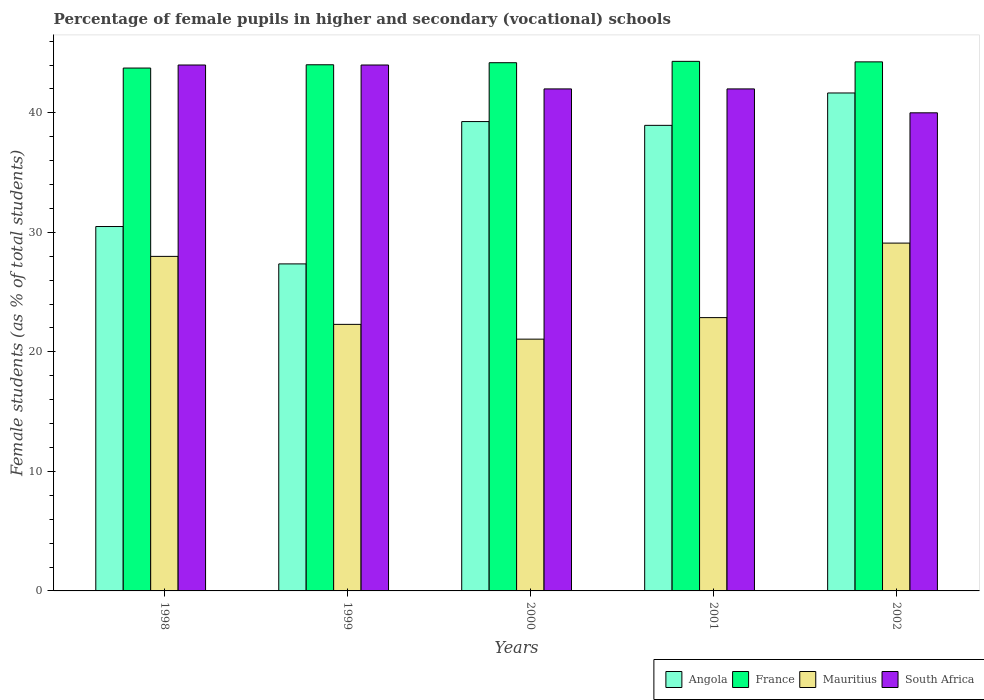How many different coloured bars are there?
Keep it short and to the point. 4. Are the number of bars on each tick of the X-axis equal?
Your answer should be compact. Yes. In how many cases, is the number of bars for a given year not equal to the number of legend labels?
Offer a terse response. 0. What is the percentage of female pupils in higher and secondary schools in France in 2002?
Provide a short and direct response. 44.26. Across all years, what is the maximum percentage of female pupils in higher and secondary schools in Mauritius?
Give a very brief answer. 29.1. Across all years, what is the minimum percentage of female pupils in higher and secondary schools in France?
Offer a very short reply. 43.74. In which year was the percentage of female pupils in higher and secondary schools in France maximum?
Your answer should be compact. 2001. In which year was the percentage of female pupils in higher and secondary schools in South Africa minimum?
Offer a terse response. 2002. What is the total percentage of female pupils in higher and secondary schools in Angola in the graph?
Make the answer very short. 177.72. What is the difference between the percentage of female pupils in higher and secondary schools in Mauritius in 1998 and that in 2001?
Offer a very short reply. 5.12. What is the difference between the percentage of female pupils in higher and secondary schools in France in 1998 and the percentage of female pupils in higher and secondary schools in Mauritius in 2001?
Keep it short and to the point. 20.88. What is the average percentage of female pupils in higher and secondary schools in Angola per year?
Give a very brief answer. 35.54. In the year 1998, what is the difference between the percentage of female pupils in higher and secondary schools in France and percentage of female pupils in higher and secondary schools in South Africa?
Keep it short and to the point. -0.26. What is the ratio of the percentage of female pupils in higher and secondary schools in Angola in 2000 to that in 2002?
Give a very brief answer. 0.94. Is the difference between the percentage of female pupils in higher and secondary schools in France in 1998 and 1999 greater than the difference between the percentage of female pupils in higher and secondary schools in South Africa in 1998 and 1999?
Provide a short and direct response. No. What is the difference between the highest and the second highest percentage of female pupils in higher and secondary schools in France?
Your answer should be very brief. 0.04. What is the difference between the highest and the lowest percentage of female pupils in higher and secondary schools in South Africa?
Your answer should be compact. 4. In how many years, is the percentage of female pupils in higher and secondary schools in South Africa greater than the average percentage of female pupils in higher and secondary schools in South Africa taken over all years?
Your response must be concise. 2. Is the sum of the percentage of female pupils in higher and secondary schools in Angola in 1999 and 2000 greater than the maximum percentage of female pupils in higher and secondary schools in Mauritius across all years?
Ensure brevity in your answer.  Yes. Is it the case that in every year, the sum of the percentage of female pupils in higher and secondary schools in Mauritius and percentage of female pupils in higher and secondary schools in Angola is greater than the sum of percentage of female pupils in higher and secondary schools in South Africa and percentage of female pupils in higher and secondary schools in France?
Give a very brief answer. No. What does the 3rd bar from the left in 2001 represents?
Your response must be concise. Mauritius. What does the 2nd bar from the right in 1999 represents?
Give a very brief answer. Mauritius. Are all the bars in the graph horizontal?
Provide a succinct answer. No. Does the graph contain any zero values?
Your answer should be compact. No. Where does the legend appear in the graph?
Offer a very short reply. Bottom right. How many legend labels are there?
Ensure brevity in your answer.  4. What is the title of the graph?
Give a very brief answer. Percentage of female pupils in higher and secondary (vocational) schools. What is the label or title of the X-axis?
Offer a very short reply. Years. What is the label or title of the Y-axis?
Ensure brevity in your answer.  Female students (as % of total students). What is the Female students (as % of total students) in Angola in 1998?
Your answer should be compact. 30.49. What is the Female students (as % of total students) in France in 1998?
Keep it short and to the point. 43.74. What is the Female students (as % of total students) in Mauritius in 1998?
Offer a terse response. 27.99. What is the Female students (as % of total students) of South Africa in 1998?
Give a very brief answer. 44. What is the Female students (as % of total students) of Angola in 1999?
Your answer should be compact. 27.36. What is the Female students (as % of total students) of France in 1999?
Offer a terse response. 44.02. What is the Female students (as % of total students) in Mauritius in 1999?
Your answer should be compact. 22.3. What is the Female students (as % of total students) of South Africa in 1999?
Give a very brief answer. 44. What is the Female students (as % of total students) of Angola in 2000?
Give a very brief answer. 39.27. What is the Female students (as % of total students) of France in 2000?
Make the answer very short. 44.19. What is the Female students (as % of total students) of Mauritius in 2000?
Ensure brevity in your answer.  21.06. What is the Female students (as % of total students) in South Africa in 2000?
Provide a succinct answer. 42. What is the Female students (as % of total students) of Angola in 2001?
Your answer should be compact. 38.95. What is the Female students (as % of total students) in France in 2001?
Provide a short and direct response. 44.31. What is the Female students (as % of total students) in Mauritius in 2001?
Make the answer very short. 22.86. What is the Female students (as % of total students) of South Africa in 2001?
Provide a succinct answer. 42. What is the Female students (as % of total students) of Angola in 2002?
Provide a succinct answer. 41.66. What is the Female students (as % of total students) of France in 2002?
Offer a terse response. 44.26. What is the Female students (as % of total students) of Mauritius in 2002?
Ensure brevity in your answer.  29.1. What is the Female students (as % of total students) of South Africa in 2002?
Offer a terse response. 40. Across all years, what is the maximum Female students (as % of total students) of Angola?
Make the answer very short. 41.66. Across all years, what is the maximum Female students (as % of total students) in France?
Make the answer very short. 44.31. Across all years, what is the maximum Female students (as % of total students) of Mauritius?
Provide a succinct answer. 29.1. Across all years, what is the maximum Female students (as % of total students) of South Africa?
Provide a succinct answer. 44. Across all years, what is the minimum Female students (as % of total students) in Angola?
Ensure brevity in your answer.  27.36. Across all years, what is the minimum Female students (as % of total students) in France?
Make the answer very short. 43.74. Across all years, what is the minimum Female students (as % of total students) in Mauritius?
Your answer should be very brief. 21.06. Across all years, what is the minimum Female students (as % of total students) of South Africa?
Ensure brevity in your answer.  40. What is the total Female students (as % of total students) of Angola in the graph?
Keep it short and to the point. 177.72. What is the total Female students (as % of total students) in France in the graph?
Provide a succinct answer. 220.52. What is the total Female students (as % of total students) in Mauritius in the graph?
Your response must be concise. 123.32. What is the total Female students (as % of total students) of South Africa in the graph?
Give a very brief answer. 212. What is the difference between the Female students (as % of total students) of Angola in 1998 and that in 1999?
Provide a short and direct response. 3.13. What is the difference between the Female students (as % of total students) of France in 1998 and that in 1999?
Offer a terse response. -0.27. What is the difference between the Female students (as % of total students) in Mauritius in 1998 and that in 1999?
Give a very brief answer. 5.69. What is the difference between the Female students (as % of total students) of Angola in 1998 and that in 2000?
Your answer should be very brief. -8.78. What is the difference between the Female students (as % of total students) of France in 1998 and that in 2000?
Provide a short and direct response. -0.45. What is the difference between the Female students (as % of total students) in Mauritius in 1998 and that in 2000?
Your answer should be very brief. 6.92. What is the difference between the Female students (as % of total students) of South Africa in 1998 and that in 2000?
Ensure brevity in your answer.  2. What is the difference between the Female students (as % of total students) in Angola in 1998 and that in 2001?
Your response must be concise. -8.46. What is the difference between the Female students (as % of total students) of France in 1998 and that in 2001?
Make the answer very short. -0.56. What is the difference between the Female students (as % of total students) of Mauritius in 1998 and that in 2001?
Keep it short and to the point. 5.12. What is the difference between the Female students (as % of total students) of South Africa in 1998 and that in 2001?
Offer a very short reply. 2. What is the difference between the Female students (as % of total students) of Angola in 1998 and that in 2002?
Provide a succinct answer. -11.17. What is the difference between the Female students (as % of total students) of France in 1998 and that in 2002?
Your response must be concise. -0.52. What is the difference between the Female students (as % of total students) in Mauritius in 1998 and that in 2002?
Offer a terse response. -1.11. What is the difference between the Female students (as % of total students) of South Africa in 1998 and that in 2002?
Offer a very short reply. 4. What is the difference between the Female students (as % of total students) in Angola in 1999 and that in 2000?
Your answer should be compact. -11.91. What is the difference between the Female students (as % of total students) of France in 1999 and that in 2000?
Your answer should be compact. -0.17. What is the difference between the Female students (as % of total students) in Mauritius in 1999 and that in 2000?
Your answer should be compact. 1.24. What is the difference between the Female students (as % of total students) in South Africa in 1999 and that in 2000?
Offer a very short reply. 2. What is the difference between the Female students (as % of total students) of Angola in 1999 and that in 2001?
Keep it short and to the point. -11.59. What is the difference between the Female students (as % of total students) in France in 1999 and that in 2001?
Ensure brevity in your answer.  -0.29. What is the difference between the Female students (as % of total students) in Mauritius in 1999 and that in 2001?
Offer a very short reply. -0.56. What is the difference between the Female students (as % of total students) of South Africa in 1999 and that in 2001?
Offer a very short reply. 2. What is the difference between the Female students (as % of total students) of Angola in 1999 and that in 2002?
Ensure brevity in your answer.  -14.3. What is the difference between the Female students (as % of total students) of France in 1999 and that in 2002?
Give a very brief answer. -0.24. What is the difference between the Female students (as % of total students) in Mauritius in 1999 and that in 2002?
Keep it short and to the point. -6.8. What is the difference between the Female students (as % of total students) in South Africa in 1999 and that in 2002?
Your answer should be very brief. 4. What is the difference between the Female students (as % of total students) of Angola in 2000 and that in 2001?
Offer a very short reply. 0.32. What is the difference between the Female students (as % of total students) in France in 2000 and that in 2001?
Give a very brief answer. -0.11. What is the difference between the Female students (as % of total students) in Mauritius in 2000 and that in 2001?
Offer a very short reply. -1.8. What is the difference between the Female students (as % of total students) of South Africa in 2000 and that in 2001?
Ensure brevity in your answer.  0. What is the difference between the Female students (as % of total students) in Angola in 2000 and that in 2002?
Give a very brief answer. -2.39. What is the difference between the Female students (as % of total students) in France in 2000 and that in 2002?
Your answer should be very brief. -0.07. What is the difference between the Female students (as % of total students) of Mauritius in 2000 and that in 2002?
Give a very brief answer. -8.04. What is the difference between the Female students (as % of total students) of South Africa in 2000 and that in 2002?
Provide a succinct answer. 2. What is the difference between the Female students (as % of total students) in Angola in 2001 and that in 2002?
Your answer should be compact. -2.71. What is the difference between the Female students (as % of total students) in France in 2001 and that in 2002?
Your response must be concise. 0.04. What is the difference between the Female students (as % of total students) in Mauritius in 2001 and that in 2002?
Your response must be concise. -6.24. What is the difference between the Female students (as % of total students) in South Africa in 2001 and that in 2002?
Offer a very short reply. 2. What is the difference between the Female students (as % of total students) in Angola in 1998 and the Female students (as % of total students) in France in 1999?
Your response must be concise. -13.53. What is the difference between the Female students (as % of total students) in Angola in 1998 and the Female students (as % of total students) in Mauritius in 1999?
Keep it short and to the point. 8.19. What is the difference between the Female students (as % of total students) in Angola in 1998 and the Female students (as % of total students) in South Africa in 1999?
Offer a very short reply. -13.51. What is the difference between the Female students (as % of total students) in France in 1998 and the Female students (as % of total students) in Mauritius in 1999?
Ensure brevity in your answer.  21.44. What is the difference between the Female students (as % of total students) in France in 1998 and the Female students (as % of total students) in South Africa in 1999?
Offer a very short reply. -0.26. What is the difference between the Female students (as % of total students) of Mauritius in 1998 and the Female students (as % of total students) of South Africa in 1999?
Make the answer very short. -16.01. What is the difference between the Female students (as % of total students) of Angola in 1998 and the Female students (as % of total students) of France in 2000?
Make the answer very short. -13.71. What is the difference between the Female students (as % of total students) in Angola in 1998 and the Female students (as % of total students) in Mauritius in 2000?
Ensure brevity in your answer.  9.42. What is the difference between the Female students (as % of total students) in Angola in 1998 and the Female students (as % of total students) in South Africa in 2000?
Your answer should be compact. -11.51. What is the difference between the Female students (as % of total students) in France in 1998 and the Female students (as % of total students) in Mauritius in 2000?
Make the answer very short. 22.68. What is the difference between the Female students (as % of total students) of France in 1998 and the Female students (as % of total students) of South Africa in 2000?
Make the answer very short. 1.74. What is the difference between the Female students (as % of total students) in Mauritius in 1998 and the Female students (as % of total students) in South Africa in 2000?
Offer a terse response. -14.01. What is the difference between the Female students (as % of total students) of Angola in 1998 and the Female students (as % of total students) of France in 2001?
Ensure brevity in your answer.  -13.82. What is the difference between the Female students (as % of total students) of Angola in 1998 and the Female students (as % of total students) of Mauritius in 2001?
Your answer should be compact. 7.62. What is the difference between the Female students (as % of total students) in Angola in 1998 and the Female students (as % of total students) in South Africa in 2001?
Provide a succinct answer. -11.51. What is the difference between the Female students (as % of total students) of France in 1998 and the Female students (as % of total students) of Mauritius in 2001?
Keep it short and to the point. 20.88. What is the difference between the Female students (as % of total students) in France in 1998 and the Female students (as % of total students) in South Africa in 2001?
Make the answer very short. 1.74. What is the difference between the Female students (as % of total students) in Mauritius in 1998 and the Female students (as % of total students) in South Africa in 2001?
Offer a very short reply. -14.01. What is the difference between the Female students (as % of total students) in Angola in 1998 and the Female students (as % of total students) in France in 2002?
Ensure brevity in your answer.  -13.78. What is the difference between the Female students (as % of total students) in Angola in 1998 and the Female students (as % of total students) in Mauritius in 2002?
Give a very brief answer. 1.39. What is the difference between the Female students (as % of total students) in Angola in 1998 and the Female students (as % of total students) in South Africa in 2002?
Offer a terse response. -9.51. What is the difference between the Female students (as % of total students) in France in 1998 and the Female students (as % of total students) in Mauritius in 2002?
Your answer should be very brief. 14.64. What is the difference between the Female students (as % of total students) in France in 1998 and the Female students (as % of total students) in South Africa in 2002?
Provide a succinct answer. 3.74. What is the difference between the Female students (as % of total students) of Mauritius in 1998 and the Female students (as % of total students) of South Africa in 2002?
Your response must be concise. -12.01. What is the difference between the Female students (as % of total students) in Angola in 1999 and the Female students (as % of total students) in France in 2000?
Keep it short and to the point. -16.83. What is the difference between the Female students (as % of total students) in Angola in 1999 and the Female students (as % of total students) in Mauritius in 2000?
Keep it short and to the point. 6.3. What is the difference between the Female students (as % of total students) of Angola in 1999 and the Female students (as % of total students) of South Africa in 2000?
Offer a very short reply. -14.64. What is the difference between the Female students (as % of total students) of France in 1999 and the Female students (as % of total students) of Mauritius in 2000?
Provide a succinct answer. 22.96. What is the difference between the Female students (as % of total students) in France in 1999 and the Female students (as % of total students) in South Africa in 2000?
Your answer should be very brief. 2.02. What is the difference between the Female students (as % of total students) of Mauritius in 1999 and the Female students (as % of total students) of South Africa in 2000?
Make the answer very short. -19.7. What is the difference between the Female students (as % of total students) of Angola in 1999 and the Female students (as % of total students) of France in 2001?
Provide a succinct answer. -16.95. What is the difference between the Female students (as % of total students) in Angola in 1999 and the Female students (as % of total students) in Mauritius in 2001?
Your response must be concise. 4.49. What is the difference between the Female students (as % of total students) in Angola in 1999 and the Female students (as % of total students) in South Africa in 2001?
Ensure brevity in your answer.  -14.64. What is the difference between the Female students (as % of total students) of France in 1999 and the Female students (as % of total students) of Mauritius in 2001?
Make the answer very short. 21.15. What is the difference between the Female students (as % of total students) of France in 1999 and the Female students (as % of total students) of South Africa in 2001?
Keep it short and to the point. 2.02. What is the difference between the Female students (as % of total students) of Mauritius in 1999 and the Female students (as % of total students) of South Africa in 2001?
Provide a succinct answer. -19.7. What is the difference between the Female students (as % of total students) of Angola in 1999 and the Female students (as % of total students) of France in 2002?
Offer a very short reply. -16.9. What is the difference between the Female students (as % of total students) in Angola in 1999 and the Female students (as % of total students) in Mauritius in 2002?
Your answer should be compact. -1.74. What is the difference between the Female students (as % of total students) of Angola in 1999 and the Female students (as % of total students) of South Africa in 2002?
Offer a terse response. -12.64. What is the difference between the Female students (as % of total students) in France in 1999 and the Female students (as % of total students) in Mauritius in 2002?
Your response must be concise. 14.92. What is the difference between the Female students (as % of total students) of France in 1999 and the Female students (as % of total students) of South Africa in 2002?
Ensure brevity in your answer.  4.02. What is the difference between the Female students (as % of total students) of Mauritius in 1999 and the Female students (as % of total students) of South Africa in 2002?
Keep it short and to the point. -17.7. What is the difference between the Female students (as % of total students) in Angola in 2000 and the Female students (as % of total students) in France in 2001?
Make the answer very short. -5.04. What is the difference between the Female students (as % of total students) of Angola in 2000 and the Female students (as % of total students) of Mauritius in 2001?
Make the answer very short. 16.4. What is the difference between the Female students (as % of total students) of Angola in 2000 and the Female students (as % of total students) of South Africa in 2001?
Ensure brevity in your answer.  -2.73. What is the difference between the Female students (as % of total students) in France in 2000 and the Female students (as % of total students) in Mauritius in 2001?
Your answer should be compact. 21.33. What is the difference between the Female students (as % of total students) of France in 2000 and the Female students (as % of total students) of South Africa in 2001?
Keep it short and to the point. 2.19. What is the difference between the Female students (as % of total students) in Mauritius in 2000 and the Female students (as % of total students) in South Africa in 2001?
Provide a short and direct response. -20.94. What is the difference between the Female students (as % of total students) in Angola in 2000 and the Female students (as % of total students) in France in 2002?
Provide a short and direct response. -5. What is the difference between the Female students (as % of total students) of Angola in 2000 and the Female students (as % of total students) of Mauritius in 2002?
Provide a short and direct response. 10.17. What is the difference between the Female students (as % of total students) in Angola in 2000 and the Female students (as % of total students) in South Africa in 2002?
Your answer should be very brief. -0.73. What is the difference between the Female students (as % of total students) of France in 2000 and the Female students (as % of total students) of Mauritius in 2002?
Your answer should be very brief. 15.09. What is the difference between the Female students (as % of total students) in France in 2000 and the Female students (as % of total students) in South Africa in 2002?
Offer a terse response. 4.19. What is the difference between the Female students (as % of total students) in Mauritius in 2000 and the Female students (as % of total students) in South Africa in 2002?
Keep it short and to the point. -18.94. What is the difference between the Female students (as % of total students) of Angola in 2001 and the Female students (as % of total students) of France in 2002?
Your answer should be compact. -5.31. What is the difference between the Female students (as % of total students) in Angola in 2001 and the Female students (as % of total students) in Mauritius in 2002?
Make the answer very short. 9.85. What is the difference between the Female students (as % of total students) of Angola in 2001 and the Female students (as % of total students) of South Africa in 2002?
Your response must be concise. -1.05. What is the difference between the Female students (as % of total students) of France in 2001 and the Female students (as % of total students) of Mauritius in 2002?
Your response must be concise. 15.21. What is the difference between the Female students (as % of total students) in France in 2001 and the Female students (as % of total students) in South Africa in 2002?
Ensure brevity in your answer.  4.31. What is the difference between the Female students (as % of total students) in Mauritius in 2001 and the Female students (as % of total students) in South Africa in 2002?
Ensure brevity in your answer.  -17.13. What is the average Female students (as % of total students) in Angola per year?
Give a very brief answer. 35.54. What is the average Female students (as % of total students) of France per year?
Offer a terse response. 44.1. What is the average Female students (as % of total students) in Mauritius per year?
Make the answer very short. 24.66. What is the average Female students (as % of total students) in South Africa per year?
Provide a short and direct response. 42.4. In the year 1998, what is the difference between the Female students (as % of total students) in Angola and Female students (as % of total students) in France?
Ensure brevity in your answer.  -13.26. In the year 1998, what is the difference between the Female students (as % of total students) of Angola and Female students (as % of total students) of Mauritius?
Your response must be concise. 2.5. In the year 1998, what is the difference between the Female students (as % of total students) in Angola and Female students (as % of total students) in South Africa?
Give a very brief answer. -13.51. In the year 1998, what is the difference between the Female students (as % of total students) of France and Female students (as % of total students) of Mauritius?
Keep it short and to the point. 15.76. In the year 1998, what is the difference between the Female students (as % of total students) of France and Female students (as % of total students) of South Africa?
Make the answer very short. -0.26. In the year 1998, what is the difference between the Female students (as % of total students) in Mauritius and Female students (as % of total students) in South Africa?
Your answer should be compact. -16.01. In the year 1999, what is the difference between the Female students (as % of total students) of Angola and Female students (as % of total students) of France?
Your answer should be very brief. -16.66. In the year 1999, what is the difference between the Female students (as % of total students) in Angola and Female students (as % of total students) in Mauritius?
Your answer should be compact. 5.06. In the year 1999, what is the difference between the Female students (as % of total students) of Angola and Female students (as % of total students) of South Africa?
Keep it short and to the point. -16.64. In the year 1999, what is the difference between the Female students (as % of total students) in France and Female students (as % of total students) in Mauritius?
Your answer should be very brief. 21.72. In the year 1999, what is the difference between the Female students (as % of total students) of France and Female students (as % of total students) of South Africa?
Offer a very short reply. 0.02. In the year 1999, what is the difference between the Female students (as % of total students) of Mauritius and Female students (as % of total students) of South Africa?
Your answer should be very brief. -21.7. In the year 2000, what is the difference between the Female students (as % of total students) of Angola and Female students (as % of total students) of France?
Ensure brevity in your answer.  -4.93. In the year 2000, what is the difference between the Female students (as % of total students) of Angola and Female students (as % of total students) of Mauritius?
Your answer should be very brief. 18.2. In the year 2000, what is the difference between the Female students (as % of total students) in Angola and Female students (as % of total students) in South Africa?
Offer a terse response. -2.73. In the year 2000, what is the difference between the Female students (as % of total students) in France and Female students (as % of total students) in Mauritius?
Provide a short and direct response. 23.13. In the year 2000, what is the difference between the Female students (as % of total students) of France and Female students (as % of total students) of South Africa?
Offer a terse response. 2.19. In the year 2000, what is the difference between the Female students (as % of total students) of Mauritius and Female students (as % of total students) of South Africa?
Provide a short and direct response. -20.94. In the year 2001, what is the difference between the Female students (as % of total students) in Angola and Female students (as % of total students) in France?
Give a very brief answer. -5.35. In the year 2001, what is the difference between the Female students (as % of total students) in Angola and Female students (as % of total students) in Mauritius?
Your response must be concise. 16.09. In the year 2001, what is the difference between the Female students (as % of total students) in Angola and Female students (as % of total students) in South Africa?
Keep it short and to the point. -3.05. In the year 2001, what is the difference between the Female students (as % of total students) of France and Female students (as % of total students) of Mauritius?
Give a very brief answer. 21.44. In the year 2001, what is the difference between the Female students (as % of total students) of France and Female students (as % of total students) of South Africa?
Your answer should be compact. 2.31. In the year 2001, what is the difference between the Female students (as % of total students) in Mauritius and Female students (as % of total students) in South Africa?
Your answer should be very brief. -19.14. In the year 2002, what is the difference between the Female students (as % of total students) of Angola and Female students (as % of total students) of France?
Provide a short and direct response. -2.6. In the year 2002, what is the difference between the Female students (as % of total students) of Angola and Female students (as % of total students) of Mauritius?
Offer a terse response. 12.56. In the year 2002, what is the difference between the Female students (as % of total students) of Angola and Female students (as % of total students) of South Africa?
Your answer should be very brief. 1.66. In the year 2002, what is the difference between the Female students (as % of total students) in France and Female students (as % of total students) in Mauritius?
Provide a succinct answer. 15.16. In the year 2002, what is the difference between the Female students (as % of total students) in France and Female students (as % of total students) in South Africa?
Offer a terse response. 4.26. In the year 2002, what is the difference between the Female students (as % of total students) of Mauritius and Female students (as % of total students) of South Africa?
Your response must be concise. -10.9. What is the ratio of the Female students (as % of total students) in Angola in 1998 to that in 1999?
Keep it short and to the point. 1.11. What is the ratio of the Female students (as % of total students) in Mauritius in 1998 to that in 1999?
Make the answer very short. 1.25. What is the ratio of the Female students (as % of total students) of Angola in 1998 to that in 2000?
Offer a very short reply. 0.78. What is the ratio of the Female students (as % of total students) in France in 1998 to that in 2000?
Ensure brevity in your answer.  0.99. What is the ratio of the Female students (as % of total students) in Mauritius in 1998 to that in 2000?
Ensure brevity in your answer.  1.33. What is the ratio of the Female students (as % of total students) in South Africa in 1998 to that in 2000?
Give a very brief answer. 1.05. What is the ratio of the Female students (as % of total students) of Angola in 1998 to that in 2001?
Your answer should be very brief. 0.78. What is the ratio of the Female students (as % of total students) in France in 1998 to that in 2001?
Offer a terse response. 0.99. What is the ratio of the Female students (as % of total students) of Mauritius in 1998 to that in 2001?
Provide a short and direct response. 1.22. What is the ratio of the Female students (as % of total students) of South Africa in 1998 to that in 2001?
Provide a succinct answer. 1.05. What is the ratio of the Female students (as % of total students) in Angola in 1998 to that in 2002?
Make the answer very short. 0.73. What is the ratio of the Female students (as % of total students) of France in 1998 to that in 2002?
Provide a succinct answer. 0.99. What is the ratio of the Female students (as % of total students) of Mauritius in 1998 to that in 2002?
Give a very brief answer. 0.96. What is the ratio of the Female students (as % of total students) of South Africa in 1998 to that in 2002?
Provide a succinct answer. 1.1. What is the ratio of the Female students (as % of total students) in Angola in 1999 to that in 2000?
Keep it short and to the point. 0.7. What is the ratio of the Female students (as % of total students) in France in 1999 to that in 2000?
Provide a succinct answer. 1. What is the ratio of the Female students (as % of total students) of Mauritius in 1999 to that in 2000?
Keep it short and to the point. 1.06. What is the ratio of the Female students (as % of total students) in South Africa in 1999 to that in 2000?
Your answer should be very brief. 1.05. What is the ratio of the Female students (as % of total students) of Angola in 1999 to that in 2001?
Ensure brevity in your answer.  0.7. What is the ratio of the Female students (as % of total students) in Mauritius in 1999 to that in 2001?
Offer a terse response. 0.98. What is the ratio of the Female students (as % of total students) of South Africa in 1999 to that in 2001?
Offer a very short reply. 1.05. What is the ratio of the Female students (as % of total students) of Angola in 1999 to that in 2002?
Keep it short and to the point. 0.66. What is the ratio of the Female students (as % of total students) in France in 1999 to that in 2002?
Make the answer very short. 0.99. What is the ratio of the Female students (as % of total students) in Mauritius in 1999 to that in 2002?
Provide a short and direct response. 0.77. What is the ratio of the Female students (as % of total students) of Angola in 2000 to that in 2001?
Offer a very short reply. 1.01. What is the ratio of the Female students (as % of total students) of France in 2000 to that in 2001?
Give a very brief answer. 1. What is the ratio of the Female students (as % of total students) of Mauritius in 2000 to that in 2001?
Your answer should be compact. 0.92. What is the ratio of the Female students (as % of total students) in South Africa in 2000 to that in 2001?
Your answer should be compact. 1. What is the ratio of the Female students (as % of total students) in Angola in 2000 to that in 2002?
Provide a short and direct response. 0.94. What is the ratio of the Female students (as % of total students) of France in 2000 to that in 2002?
Give a very brief answer. 1. What is the ratio of the Female students (as % of total students) of Mauritius in 2000 to that in 2002?
Keep it short and to the point. 0.72. What is the ratio of the Female students (as % of total students) in Angola in 2001 to that in 2002?
Provide a short and direct response. 0.94. What is the ratio of the Female students (as % of total students) of Mauritius in 2001 to that in 2002?
Offer a terse response. 0.79. What is the difference between the highest and the second highest Female students (as % of total students) in Angola?
Your response must be concise. 2.39. What is the difference between the highest and the second highest Female students (as % of total students) of France?
Offer a terse response. 0.04. What is the difference between the highest and the second highest Female students (as % of total students) in Mauritius?
Give a very brief answer. 1.11. What is the difference between the highest and the lowest Female students (as % of total students) of Angola?
Your answer should be very brief. 14.3. What is the difference between the highest and the lowest Female students (as % of total students) in France?
Your answer should be compact. 0.56. What is the difference between the highest and the lowest Female students (as % of total students) in Mauritius?
Your answer should be compact. 8.04. What is the difference between the highest and the lowest Female students (as % of total students) in South Africa?
Your response must be concise. 4. 